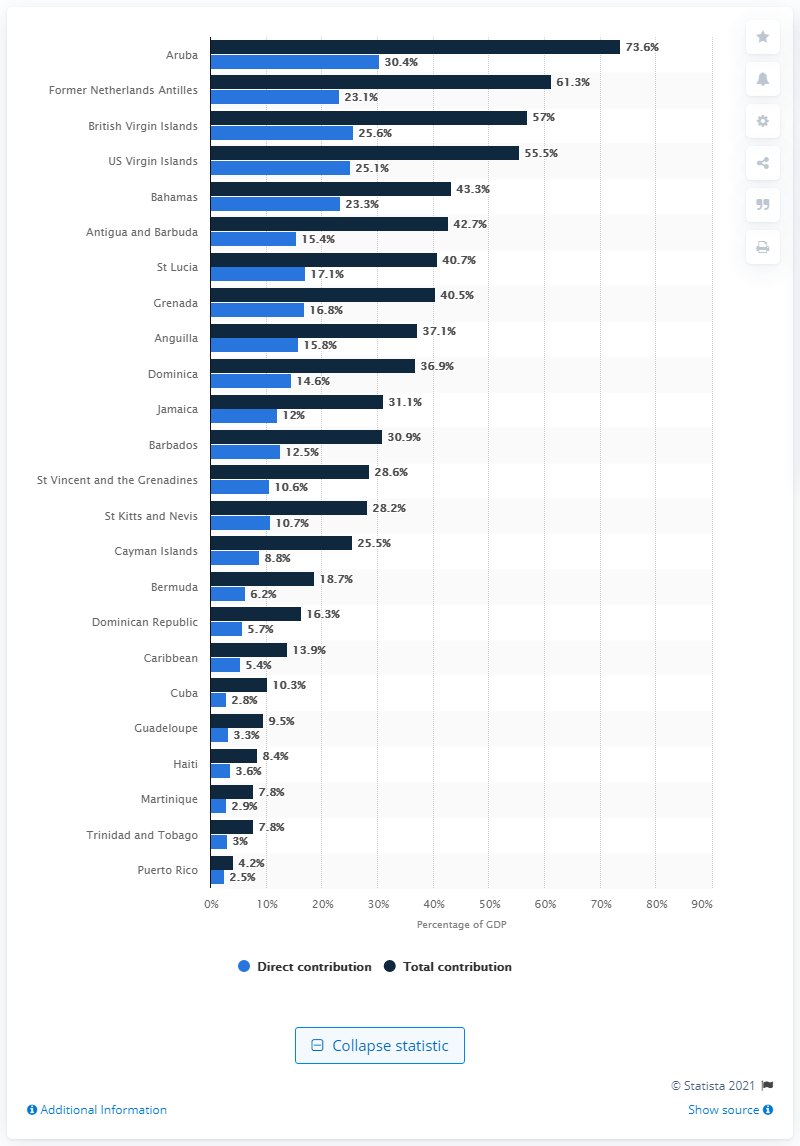Mention a couple of crucial points in this snapshot. In 2019, the travel and tourism sector accounted for 13.9% of the Caribbean's gross domestic product. 